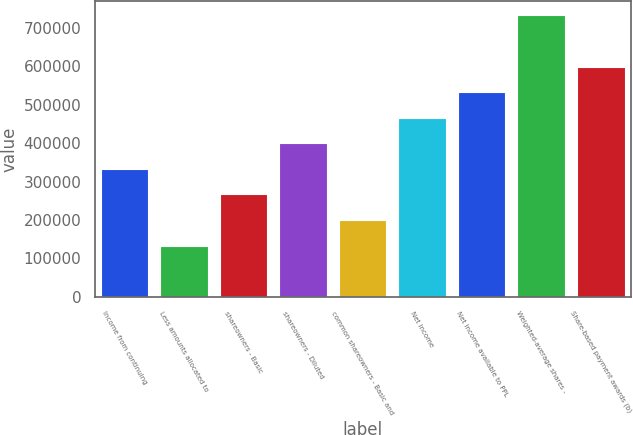Convert chart to OTSL. <chart><loc_0><loc_0><loc_500><loc_500><bar_chart><fcel>Income from continuing<fcel>Less amounts allocated to<fcel>shareowners - Basic<fcel>shareowners - Diluted<fcel>common shareowners - Basic and<fcel>Net income<fcel>Net income available to PPL<fcel>Weighted-average shares -<fcel>Share-based payment awards (b)<nl><fcel>332987<fcel>133195<fcel>266389<fcel>399584<fcel>199792<fcel>466181<fcel>532778<fcel>732570<fcel>599376<nl></chart> 